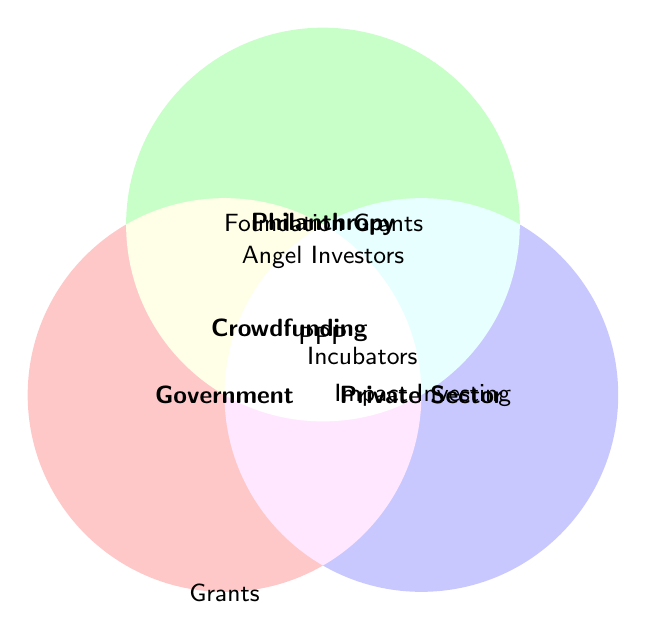What are the three main funding categories shown in the diagram? The diagram shows circles representing three main funding categories. These categories are labeled as Government, Philanthropy, and Private Sector.
Answer: Government, Philanthropy, Private Sector What funding sources are unique to the Government sector? The unique funding sources for Government are shown inside the Government circle with no overlap with other circles. These sources are "Government Grants" and "Social Impact Bonds."
Answer: Government Grants, Social Impact Bonds Which funding sources are shared between Government and Philanthropy? The shared funding sources between Government and Philanthropy are located in the overlapping area of the Government and Philanthropy circles. This shared funding source is "Public-Private Partnerships."
Answer: Public-Private Partnerships Identify a funding source that all categories have in common. The funding source common to all three categories (Government, Philanthropy, and Private Sector) is shown in the center where all three circles overlap. This source is "Crowdfunding."
Answer: Crowdfunding What type of funding comes from both Philanthropy and the Private Sector? The funding sources shared by Philanthropy and the Private Sector are located in the overlapping area of Philanthropy and Private Sector circles. These sources include "Angel Investors."
Answer: Angel Investors Which funding category includes "Impact Investing"? "Impact Investing" is shown within the Private Sector circle with no overlap with other circles. Therefore, it is unique to the Private Sector.
Answer: Private Sector How many unique funding sources are there for Philanthropy? Unique funding sources for Philanthropy are located only within the Philanthropy circle without overlapping other categories. These sources are "Foundation Grants" and "Corporate Sponsorships," making a total of 2.
Answer: 2 What is the funding source shared between Government and the Private Sector? The shared funding source between Government and the Private Sector is located where the Government and Private Sector circles overlap. This source is "Social Enterprise Incubators."
Answer: Social Enterprise Incubators Which category does "Angel Investors" belong to? "Angel Investors" are located in the overlapping area between Philanthropy and Private Sector, indicating they belong to both these categories.
Answer: Philanthropy & Private Sector Name all the funding sources unique to each of the three main categories. First, check each circle that does not overlap with others. For Government: "Government Grants," "Social Impact Bonds"; for Philanthropy: "Foundation Grants," "Corporate Sponsorships"; for Private Sector: "Impact Investing," "Venture Capital."
Answer: Government: Government Grants, Social Impact Bonds; Philanthropy: Foundation Grants, Corporate Sponsorships; Private Sector: Impact Investing, Venture Capital 